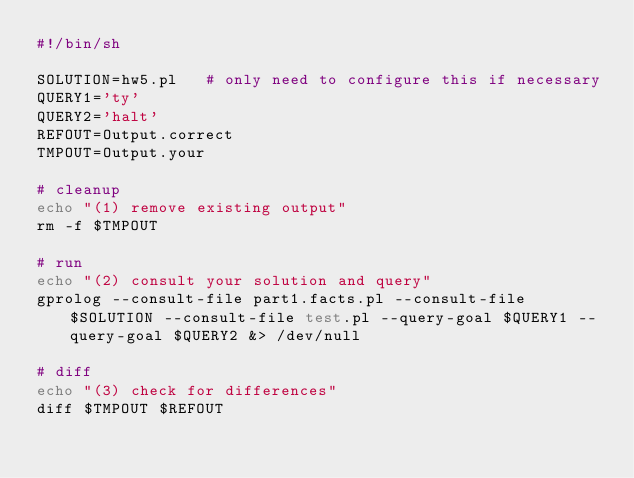Convert code to text. <code><loc_0><loc_0><loc_500><loc_500><_Bash_>#!/bin/sh 

SOLUTION=hw5.pl   # only need to configure this if necessary 
QUERY1='ty'
QUERY2='halt'
REFOUT=Output.correct 
TMPOUT=Output.your

# cleanup 
echo "(1) remove existing output"
rm -f $TMPOUT

# run 
echo "(2) consult your solution and query" 
gprolog --consult-file part1.facts.pl --consult-file $SOLUTION --consult-file test.pl --query-goal $QUERY1 --query-goal $QUERY2 &> /dev/null

# diff 
echo "(3) check for differences" 
diff $TMPOUT $REFOUT
</code> 